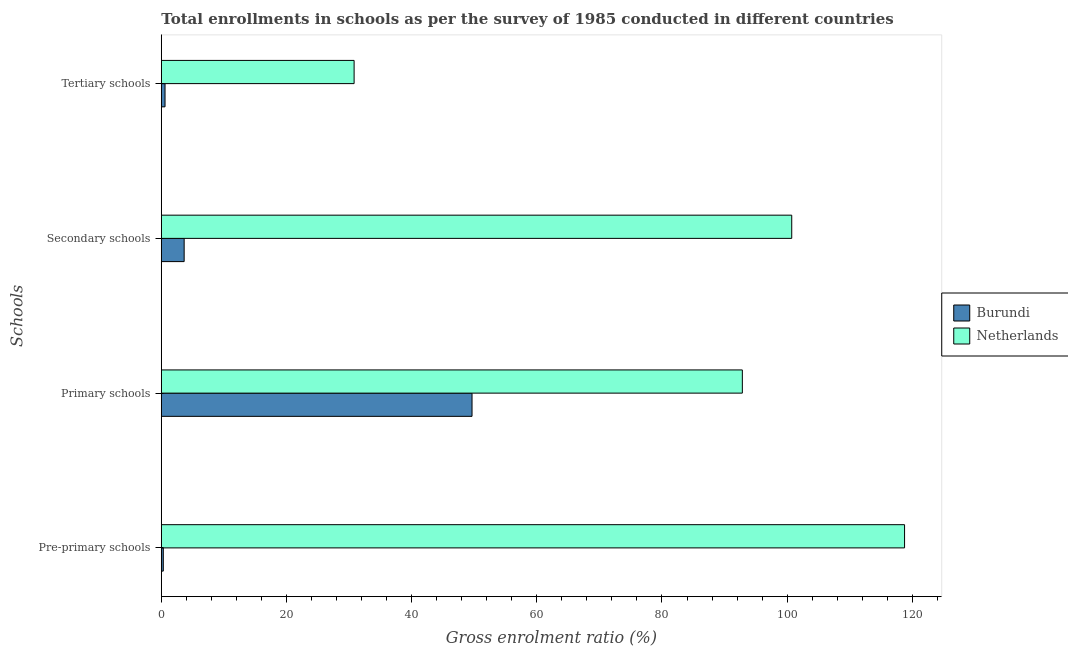How many different coloured bars are there?
Your answer should be compact. 2. How many groups of bars are there?
Your response must be concise. 4. Are the number of bars per tick equal to the number of legend labels?
Your answer should be compact. Yes. How many bars are there on the 1st tick from the bottom?
Provide a short and direct response. 2. What is the label of the 4th group of bars from the top?
Provide a short and direct response. Pre-primary schools. What is the gross enrolment ratio in secondary schools in Netherlands?
Offer a terse response. 100.73. Across all countries, what is the maximum gross enrolment ratio in tertiary schools?
Your response must be concise. 30.81. Across all countries, what is the minimum gross enrolment ratio in tertiary schools?
Offer a terse response. 0.59. In which country was the gross enrolment ratio in pre-primary schools minimum?
Offer a very short reply. Burundi. What is the total gross enrolment ratio in tertiary schools in the graph?
Your answer should be very brief. 31.4. What is the difference between the gross enrolment ratio in tertiary schools in Burundi and that in Netherlands?
Offer a terse response. -30.21. What is the difference between the gross enrolment ratio in tertiary schools in Netherlands and the gross enrolment ratio in secondary schools in Burundi?
Provide a succinct answer. 27.16. What is the average gross enrolment ratio in secondary schools per country?
Provide a succinct answer. 52.19. What is the difference between the gross enrolment ratio in pre-primary schools and gross enrolment ratio in secondary schools in Burundi?
Offer a very short reply. -3.33. What is the ratio of the gross enrolment ratio in secondary schools in Burundi to that in Netherlands?
Offer a very short reply. 0.04. Is the gross enrolment ratio in pre-primary schools in Burundi less than that in Netherlands?
Your answer should be compact. Yes. What is the difference between the highest and the second highest gross enrolment ratio in primary schools?
Provide a succinct answer. 43.19. What is the difference between the highest and the lowest gross enrolment ratio in primary schools?
Give a very brief answer. 43.19. In how many countries, is the gross enrolment ratio in primary schools greater than the average gross enrolment ratio in primary schools taken over all countries?
Make the answer very short. 1. Is the sum of the gross enrolment ratio in primary schools in Burundi and Netherlands greater than the maximum gross enrolment ratio in pre-primary schools across all countries?
Offer a very short reply. Yes. What does the 2nd bar from the top in Pre-primary schools represents?
Your answer should be compact. Burundi. What does the 1st bar from the bottom in Tertiary schools represents?
Ensure brevity in your answer.  Burundi. Is it the case that in every country, the sum of the gross enrolment ratio in pre-primary schools and gross enrolment ratio in primary schools is greater than the gross enrolment ratio in secondary schools?
Provide a succinct answer. Yes. How many bars are there?
Keep it short and to the point. 8. How many countries are there in the graph?
Your response must be concise. 2. Does the graph contain grids?
Your answer should be compact. No. How many legend labels are there?
Ensure brevity in your answer.  2. What is the title of the graph?
Keep it short and to the point. Total enrollments in schools as per the survey of 1985 conducted in different countries. Does "St. Martin (French part)" appear as one of the legend labels in the graph?
Give a very brief answer. No. What is the label or title of the Y-axis?
Give a very brief answer. Schools. What is the Gross enrolment ratio (%) in Burundi in Pre-primary schools?
Your answer should be very brief. 0.32. What is the Gross enrolment ratio (%) in Netherlands in Pre-primary schools?
Offer a very short reply. 118.76. What is the Gross enrolment ratio (%) of Burundi in Primary schools?
Provide a succinct answer. 49.65. What is the Gross enrolment ratio (%) of Netherlands in Primary schools?
Ensure brevity in your answer.  92.84. What is the Gross enrolment ratio (%) in Burundi in Secondary schools?
Your answer should be very brief. 3.65. What is the Gross enrolment ratio (%) of Netherlands in Secondary schools?
Keep it short and to the point. 100.73. What is the Gross enrolment ratio (%) of Burundi in Tertiary schools?
Offer a very short reply. 0.59. What is the Gross enrolment ratio (%) of Netherlands in Tertiary schools?
Offer a terse response. 30.81. Across all Schools, what is the maximum Gross enrolment ratio (%) of Burundi?
Your answer should be compact. 49.65. Across all Schools, what is the maximum Gross enrolment ratio (%) of Netherlands?
Keep it short and to the point. 118.76. Across all Schools, what is the minimum Gross enrolment ratio (%) in Burundi?
Keep it short and to the point. 0.32. Across all Schools, what is the minimum Gross enrolment ratio (%) in Netherlands?
Provide a succinct answer. 30.81. What is the total Gross enrolment ratio (%) of Burundi in the graph?
Your response must be concise. 54.21. What is the total Gross enrolment ratio (%) of Netherlands in the graph?
Provide a short and direct response. 343.15. What is the difference between the Gross enrolment ratio (%) in Burundi in Pre-primary schools and that in Primary schools?
Make the answer very short. -49.33. What is the difference between the Gross enrolment ratio (%) of Netherlands in Pre-primary schools and that in Primary schools?
Make the answer very short. 25.92. What is the difference between the Gross enrolment ratio (%) of Burundi in Pre-primary schools and that in Secondary schools?
Your answer should be compact. -3.33. What is the difference between the Gross enrolment ratio (%) in Netherlands in Pre-primary schools and that in Secondary schools?
Your answer should be compact. 18.03. What is the difference between the Gross enrolment ratio (%) in Burundi in Pre-primary schools and that in Tertiary schools?
Provide a succinct answer. -0.28. What is the difference between the Gross enrolment ratio (%) in Netherlands in Pre-primary schools and that in Tertiary schools?
Give a very brief answer. 87.96. What is the difference between the Gross enrolment ratio (%) of Burundi in Primary schools and that in Secondary schools?
Offer a terse response. 46. What is the difference between the Gross enrolment ratio (%) in Netherlands in Primary schools and that in Secondary schools?
Provide a succinct answer. -7.89. What is the difference between the Gross enrolment ratio (%) in Burundi in Primary schools and that in Tertiary schools?
Your response must be concise. 49.06. What is the difference between the Gross enrolment ratio (%) in Netherlands in Primary schools and that in Tertiary schools?
Your response must be concise. 62.04. What is the difference between the Gross enrolment ratio (%) in Burundi in Secondary schools and that in Tertiary schools?
Ensure brevity in your answer.  3.06. What is the difference between the Gross enrolment ratio (%) in Netherlands in Secondary schools and that in Tertiary schools?
Keep it short and to the point. 69.93. What is the difference between the Gross enrolment ratio (%) in Burundi in Pre-primary schools and the Gross enrolment ratio (%) in Netherlands in Primary schools?
Ensure brevity in your answer.  -92.53. What is the difference between the Gross enrolment ratio (%) in Burundi in Pre-primary schools and the Gross enrolment ratio (%) in Netherlands in Secondary schools?
Provide a short and direct response. -100.42. What is the difference between the Gross enrolment ratio (%) in Burundi in Pre-primary schools and the Gross enrolment ratio (%) in Netherlands in Tertiary schools?
Provide a succinct answer. -30.49. What is the difference between the Gross enrolment ratio (%) of Burundi in Primary schools and the Gross enrolment ratio (%) of Netherlands in Secondary schools?
Your response must be concise. -51.08. What is the difference between the Gross enrolment ratio (%) in Burundi in Primary schools and the Gross enrolment ratio (%) in Netherlands in Tertiary schools?
Give a very brief answer. 18.84. What is the difference between the Gross enrolment ratio (%) of Burundi in Secondary schools and the Gross enrolment ratio (%) of Netherlands in Tertiary schools?
Provide a short and direct response. -27.16. What is the average Gross enrolment ratio (%) of Burundi per Schools?
Ensure brevity in your answer.  13.55. What is the average Gross enrolment ratio (%) in Netherlands per Schools?
Offer a terse response. 85.79. What is the difference between the Gross enrolment ratio (%) in Burundi and Gross enrolment ratio (%) in Netherlands in Pre-primary schools?
Give a very brief answer. -118.45. What is the difference between the Gross enrolment ratio (%) in Burundi and Gross enrolment ratio (%) in Netherlands in Primary schools?
Offer a terse response. -43.19. What is the difference between the Gross enrolment ratio (%) in Burundi and Gross enrolment ratio (%) in Netherlands in Secondary schools?
Offer a very short reply. -97.09. What is the difference between the Gross enrolment ratio (%) in Burundi and Gross enrolment ratio (%) in Netherlands in Tertiary schools?
Keep it short and to the point. -30.21. What is the ratio of the Gross enrolment ratio (%) in Burundi in Pre-primary schools to that in Primary schools?
Make the answer very short. 0.01. What is the ratio of the Gross enrolment ratio (%) of Netherlands in Pre-primary schools to that in Primary schools?
Offer a very short reply. 1.28. What is the ratio of the Gross enrolment ratio (%) in Burundi in Pre-primary schools to that in Secondary schools?
Your answer should be very brief. 0.09. What is the ratio of the Gross enrolment ratio (%) of Netherlands in Pre-primary schools to that in Secondary schools?
Your answer should be compact. 1.18. What is the ratio of the Gross enrolment ratio (%) of Burundi in Pre-primary schools to that in Tertiary schools?
Provide a short and direct response. 0.53. What is the ratio of the Gross enrolment ratio (%) of Netherlands in Pre-primary schools to that in Tertiary schools?
Offer a very short reply. 3.86. What is the ratio of the Gross enrolment ratio (%) in Burundi in Primary schools to that in Secondary schools?
Ensure brevity in your answer.  13.61. What is the ratio of the Gross enrolment ratio (%) of Netherlands in Primary schools to that in Secondary schools?
Your answer should be very brief. 0.92. What is the ratio of the Gross enrolment ratio (%) in Burundi in Primary schools to that in Tertiary schools?
Give a very brief answer. 83.72. What is the ratio of the Gross enrolment ratio (%) in Netherlands in Primary schools to that in Tertiary schools?
Keep it short and to the point. 3.01. What is the ratio of the Gross enrolment ratio (%) of Burundi in Secondary schools to that in Tertiary schools?
Your response must be concise. 6.15. What is the ratio of the Gross enrolment ratio (%) in Netherlands in Secondary schools to that in Tertiary schools?
Keep it short and to the point. 3.27. What is the difference between the highest and the second highest Gross enrolment ratio (%) in Burundi?
Make the answer very short. 46. What is the difference between the highest and the second highest Gross enrolment ratio (%) in Netherlands?
Your answer should be very brief. 18.03. What is the difference between the highest and the lowest Gross enrolment ratio (%) in Burundi?
Your answer should be compact. 49.33. What is the difference between the highest and the lowest Gross enrolment ratio (%) of Netherlands?
Your answer should be very brief. 87.96. 